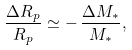<formula> <loc_0><loc_0><loc_500><loc_500>\frac { \Delta R _ { p } } { R _ { p } } \simeq - \, \frac { \Delta M _ { * } } { M _ { * } } ,</formula> 